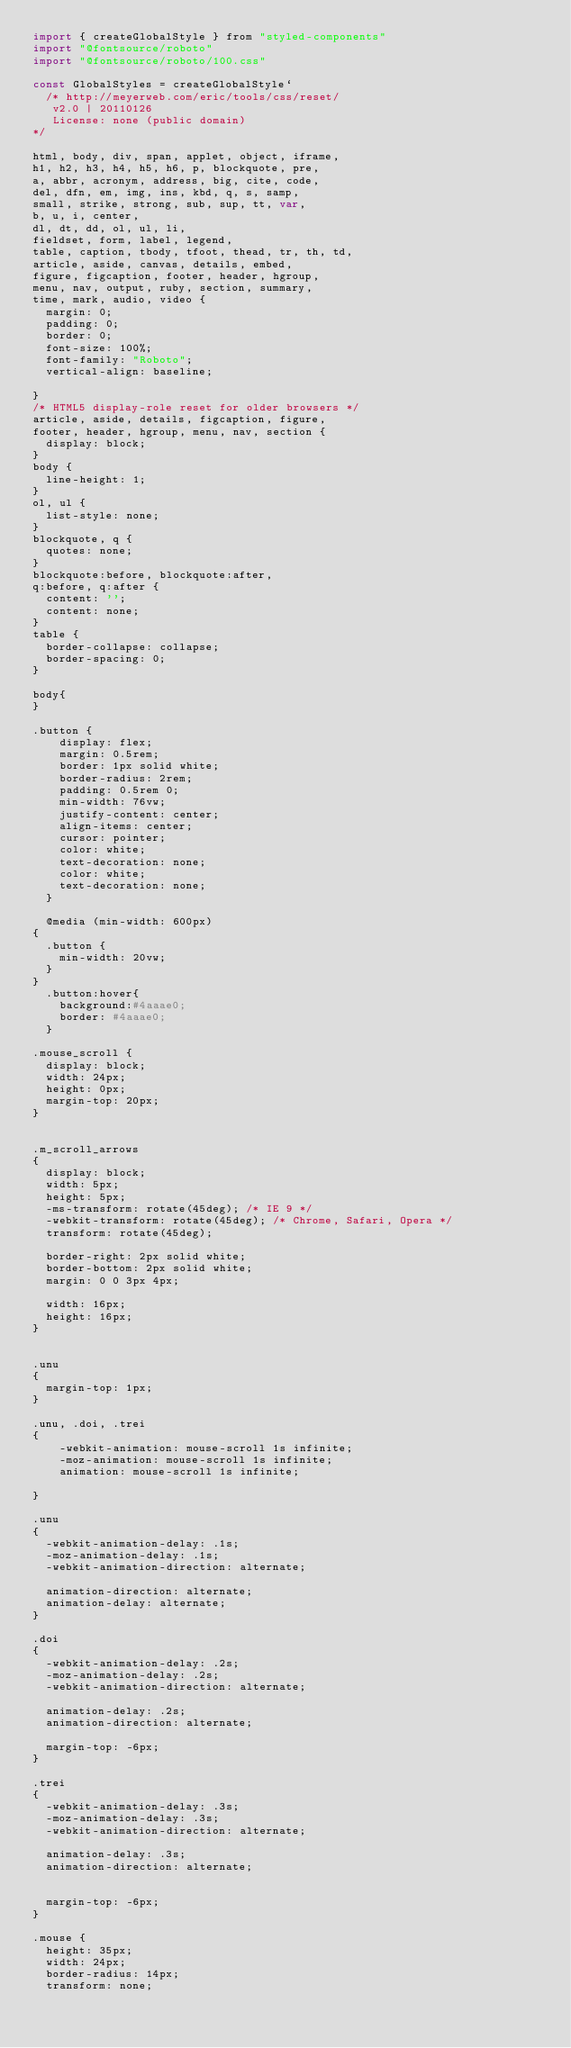Convert code to text. <code><loc_0><loc_0><loc_500><loc_500><_JavaScript_>import { createGlobalStyle } from "styled-components"
import "@fontsource/roboto"
import "@fontsource/roboto/100.css"

const GlobalStyles = createGlobalStyle`
  /* http://meyerweb.com/eric/tools/css/reset/ 
   v2.0 | 20110126
   License: none (public domain)
*/

html, body, div, span, applet, object, iframe,
h1, h2, h3, h4, h5, h6, p, blockquote, pre,
a, abbr, acronym, address, big, cite, code,
del, dfn, em, img, ins, kbd, q, s, samp,
small, strike, strong, sub, sup, tt, var,
b, u, i, center,
dl, dt, dd, ol, ul, li,
fieldset, form, label, legend,
table, caption, tbody, tfoot, thead, tr, th, td,
article, aside, canvas, details, embed, 
figure, figcaption, footer, header, hgroup, 
menu, nav, output, ruby, section, summary,
time, mark, audio, video {
	margin: 0;
	padding: 0;
	border: 0;
	font-size: 100%;
	font-family: "Roboto";
	vertical-align: baseline;

}
/* HTML5 display-role reset for older browsers */
article, aside, details, figcaption, figure, 
footer, header, hgroup, menu, nav, section {
	display: block;
}
body {
	line-height: 1;
}
ol, ul {
	list-style: none;
}
blockquote, q {
	quotes: none;
}
blockquote:before, blockquote:after,
q:before, q:after {
	content: '';
	content: none;
}
table {
	border-collapse: collapse;
	border-spacing: 0;
}

body{
}

.button {
    display: flex;
    margin: 0.5rem;
    border: 1px solid white;
    border-radius: 2rem;
    padding: 0.5rem 0;
    min-width: 76vw;
    justify-content: center;
    align-items: center;
    cursor: pointer;
    color: white;
    text-decoration: none;
    color: white;
    text-decoration: none;
  }

  @media (min-width: 600px)
{
  .button {
    min-width: 20vw;
  }
}
  .button:hover{
    background:#4aaae0;
    border: #4aaae0;
  }

.mouse_scroll {
	display: block;
	width: 24px;
	height: 0px;
	margin-top: 20px;
}


.m_scroll_arrows
{
  display: block;
  width: 5px;
  height: 5px;
  -ms-transform: rotate(45deg); /* IE 9 */
  -webkit-transform: rotate(45deg); /* Chrome, Safari, Opera */
  transform: rotate(45deg);
   
  border-right: 2px solid white;
  border-bottom: 2px solid white;
  margin: 0 0 3px 4px;
  
  width: 16px;
  height: 16px;
}


.unu
{
  margin-top: 1px;
}

.unu, .doi, .trei
{
    -webkit-animation: mouse-scroll 1s infinite;
    -moz-animation: mouse-scroll 1s infinite;
    animation: mouse-scroll 1s infinite;
  
}

.unu
{
  -webkit-animation-delay: .1s;
  -moz-animation-delay: .1s;
  -webkit-animation-direction: alternate;
  
  animation-direction: alternate;
  animation-delay: alternate;
}

.doi
{
  -webkit-animation-delay: .2s;
  -moz-animation-delay: .2s;
  -webkit-animation-direction: alternate;
  
  animation-delay: .2s;
  animation-direction: alternate;
  
  margin-top: -6px;
}

.trei
{
  -webkit-animation-delay: .3s;
  -moz-animation-delay: .3s;
  -webkit-animation-direction: alternate;
  
  animation-delay: .3s;
  animation-direction: alternate;
  
  
  margin-top: -6px;
}

.mouse {
  height: 35px;
  width: 24px;
  border-radius: 14px;
  transform: none;</code> 